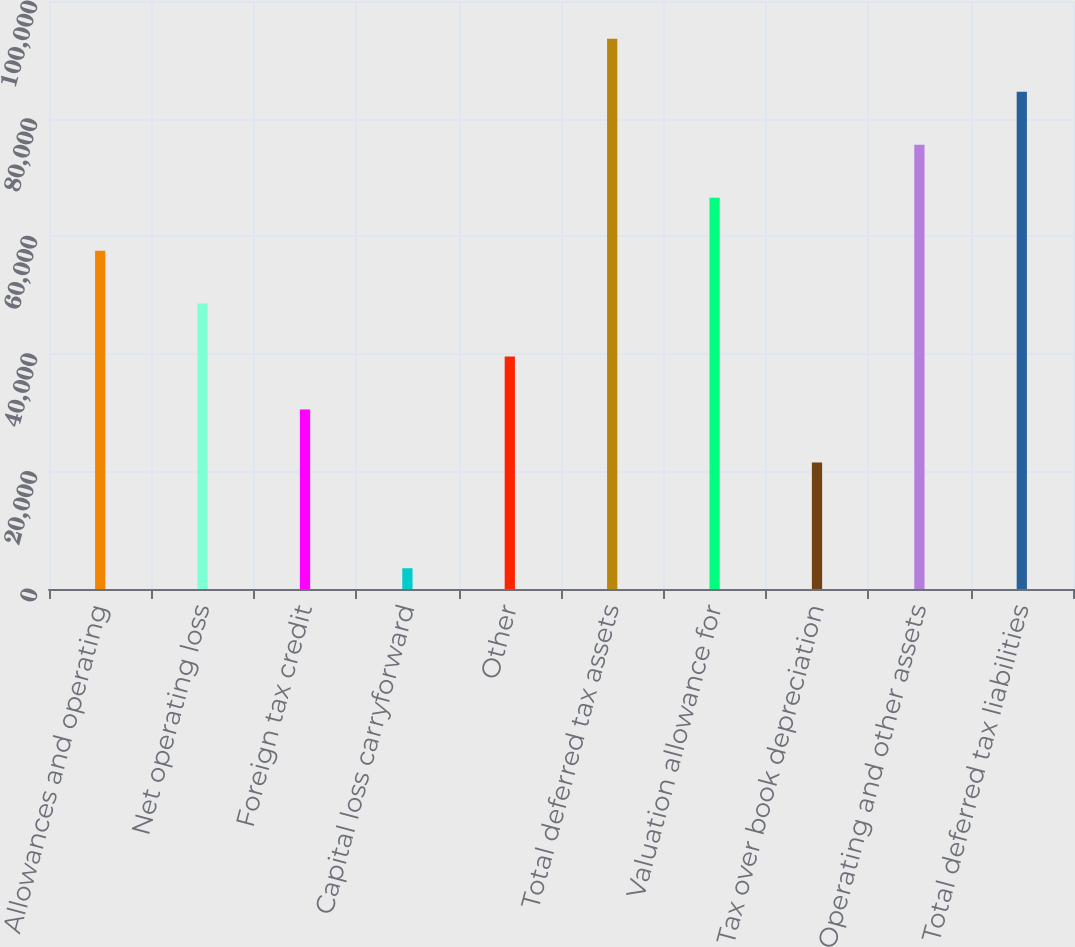<chart> <loc_0><loc_0><loc_500><loc_500><bar_chart><fcel>Allowances and operating<fcel>Net operating loss<fcel>Foreign tax credit<fcel>Capital loss carryforward<fcel>Other<fcel>Total deferred tax assets<fcel>Valuation allowance for<fcel>Tax over book depreciation<fcel>Operating and other assets<fcel>Total deferred tax liabilities<nl><fcel>57546.2<fcel>48543<fcel>30536.6<fcel>3527<fcel>39539.8<fcel>93559<fcel>66549.4<fcel>21533.4<fcel>75552.6<fcel>84555.8<nl></chart> 